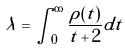Convert formula to latex. <formula><loc_0><loc_0><loc_500><loc_500>\lambda = \int _ { 0 } ^ { \infty } \frac { \rho ( t ) } { t + 2 } d t</formula> 